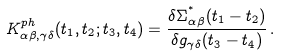Convert formula to latex. <formula><loc_0><loc_0><loc_500><loc_500>K ^ { p h } _ { \alpha \beta , \gamma \delta } ( t _ { 1 } , t _ { 2 } ; t _ { 3 } , t _ { 4 } ) = \frac { \delta \Sigma ^ { ^ { * } } _ { \alpha \beta } ( t _ { 1 } - t _ { 2 } ) } { \delta g _ { \gamma \delta } ( t _ { 3 } - t _ { 4 } ) } \, .</formula> 